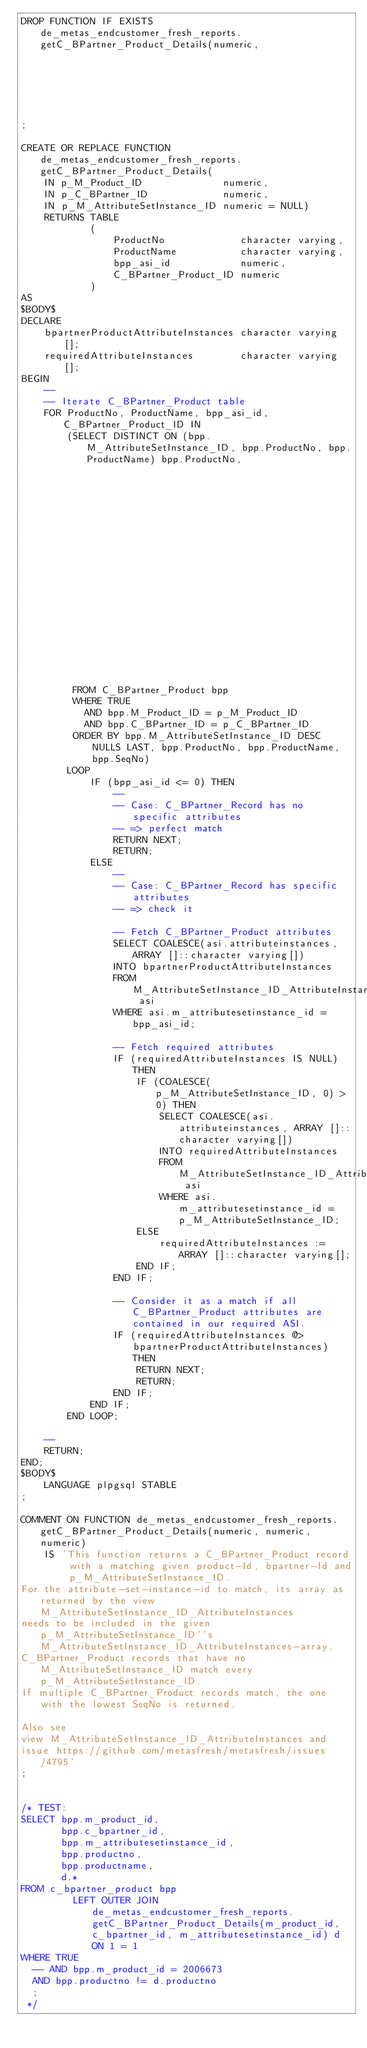Convert code to text. <code><loc_0><loc_0><loc_500><loc_500><_SQL_>DROP FUNCTION IF EXISTS de_metas_endcustomer_fresh_reports.getC_BPartner_Product_Details(numeric,
                                                                                         numeric,
                                                                                         numeric)
;

CREATE OR REPLACE FUNCTION de_metas_endcustomer_fresh_reports.getC_BPartner_Product_Details(
    IN p_M_Product_ID              numeric,
    IN p_C_BPartner_ID             numeric,
    IN p_M_AttributeSetInstance_ID numeric = NULL)
    RETURNS TABLE
            (
                ProductNo             character varying,
                ProductName           character varying,
                bpp_asi_id            numeric,
                C_BPartner_Product_ID numeric
            )
AS
$BODY$
DECLARE
    bpartnerProductAttributeInstances character varying[];
    requiredAttributeInstances        character varying[];
BEGIN
    --
    -- Iterate C_BPartner_Product table
    FOR ProductNo, ProductName, bpp_asi_id, C_BPartner_Product_ID IN
        (SELECT DISTINCT ON (bpp.M_AttributeSetInstance_ID, bpp.ProductNo, bpp.ProductName) bpp.ProductNo,
                                                                                            bpp.ProductName,
                                                                                            COALESCE(bpp.m_attributesetinstance_id, 0),
                                                                                            bpp.C_BPartner_Product_ID
         FROM C_BPartner_Product bpp
         WHERE TRUE
           AND bpp.M_Product_ID = p_M_Product_ID
           AND bpp.C_BPartner_ID = p_C_BPartner_ID
         ORDER BY bpp.M_AttributeSetInstance_ID DESC NULLS LAST, bpp.ProductNo, bpp.ProductName, bpp.SeqNo)
        LOOP
            IF (bpp_asi_id <= 0) THEN
                --
                -- Case: C_BPartner_Record has no specific attributes
                -- => perfect match
                RETURN NEXT;
                RETURN;
            ELSE
                --
                -- Case: C_BPartner_Record has specific attributes
                -- => check it

                -- Fetch C_BPartner_Product attributes
                SELECT COALESCE(asi.attributeinstances, ARRAY []::character varying[])
                INTO bpartnerProductAttributeInstances
                FROM M_AttributeSetInstance_ID_AttributeInstances asi
                WHERE asi.m_attributesetinstance_id = bpp_asi_id;

                -- Fetch required attributes
                IF (requiredAttributeInstances IS NULL) THEN
                    IF (COALESCE(p_M_AttributeSetInstance_ID, 0) > 0) THEN
                        SELECT COALESCE(asi.attributeinstances, ARRAY []::character varying[])
                        INTO requiredAttributeInstances
                        FROM M_AttributeSetInstance_ID_AttributeInstances asi
                        WHERE asi.m_attributesetinstance_id = p_M_AttributeSetInstance_ID;
                    ELSE
                        requiredAttributeInstances := ARRAY []::character varying[];
                    END IF;
                END IF;

                -- Consider it as a match if all C_BPartner_Product attributes are contained in our required ASI.
                IF (requiredAttributeInstances @> bpartnerProductAttributeInstances) THEN
                    RETURN NEXT;
                    RETURN;
                END IF;
            END IF;
        END LOOP;

    --
    RETURN;
END;
$BODY$
    LANGUAGE plpgsql STABLE
;

COMMENT ON FUNCTION de_metas_endcustomer_fresh_reports.getC_BPartner_Product_Details(numeric, numeric, numeric)
    IS 'This function returns a C_BPartner_Product record with a matching given product-Id, bpartner-Id and p_M_AttributeSetInstance_ID.
For the attribute-set-instance-id to match, its array as returned by the view M_AttributeSetInstance_ID_AttributeInstances 
needs to be included in the given p_M_AttributeSetInstance_ID''s M_AttributeSetInstance_ID_AttributeInstances-array.
C_BPartner_Product records that have no M_AttributeSetInstance_ID match every p_M_AttributeSetInstance_ID.
If multiple C_BPartner_Product records match, the one with the lowest SeqNo is returned.

Also see 
view M_AttributeSetInstance_ID_AttributeInstances and
issue https://github.com/metasfresh/metasfresh/issues/4795'
;


/* TEST:
SELECT bpp.m_product_id,
       bpp.c_bpartner_id,
       bpp.m_attributesetinstance_id,
       bpp.productno,
       bpp.productname,
       d.*
FROM c_bpartner_product bpp
         LEFT OUTER JOIN de_metas_endcustomer_fresh_reports.getC_BPartner_Product_Details(m_product_id, c_bpartner_id, m_attributesetinstance_id) d ON 1 = 1
WHERE TRUE
  -- AND bpp.m_product_id = 2006673
  AND bpp.productno != d.productno
  ;
 */

</code> 